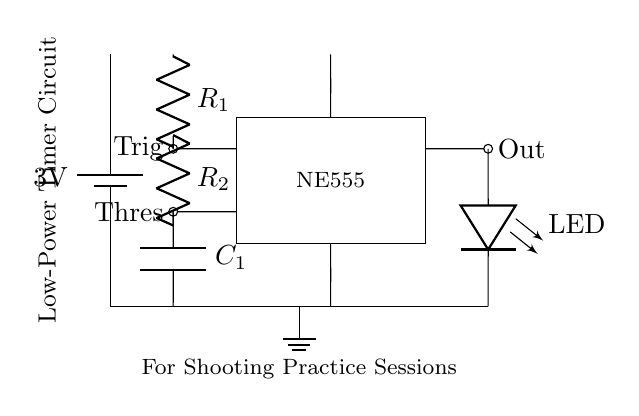What is the power supply voltage of this circuit? The circuit is powered by a battery labeled 3V. The component responsible for power supply is a battery, which is shown as a voltage source in the circuit diagram.
Answer: 3V What components are used in this timer circuit? The main components in this timer circuit are a NE555 timer, two resistors labeled R1 and R2, a capacitor labeled C1, and an LED. Each of these components is visually represented in the circuit and labeled accordingly.
Answer: NE555, R1, R2, C1, LED What is the role of the NE555 timer in this circuit? The NE555 timer functions as a timing device by controlling the output duration. It uses the trigger and threshold pins to manage when to turn on the output, which is reflected in the LED's state, defining the timing mechanism for the shooting practice sessions.
Answer: Timing device How many resistors are present in the circuit? By examining the circuit diagram, it is clear that there are two resistors, R1 and R2, visibly labeled and connected in series above the capacitor.
Answer: 2 What will happen if one of the resistors is removed? Removing a resistor would disrupt the timing mechanism provided by the NE555 timer due to changes in the charge and discharge paths for the capacitor. This would affect the timing intervals, potentially leading to incorrect timing during shooting practice.
Answer: Disrupted timing What does the LED indicate in this circuit? The LED provides a visual indication of the timer's output; when the circuit operates, the LED lights up to show that the timer is active, signaling the duration of a practice session or a specific timing event.
Answer: Visual indication of output What type of capacitor is shown in the circuit? The capacitor labeled C1 is a crucial part of the circuit that determines the timing intervals. Capacitors in timer circuits are typically electrolytic or ceramic, but the specifics are not detailed in the circuit. It serves to store and release energy during operation.
Answer: Timing capacitor 